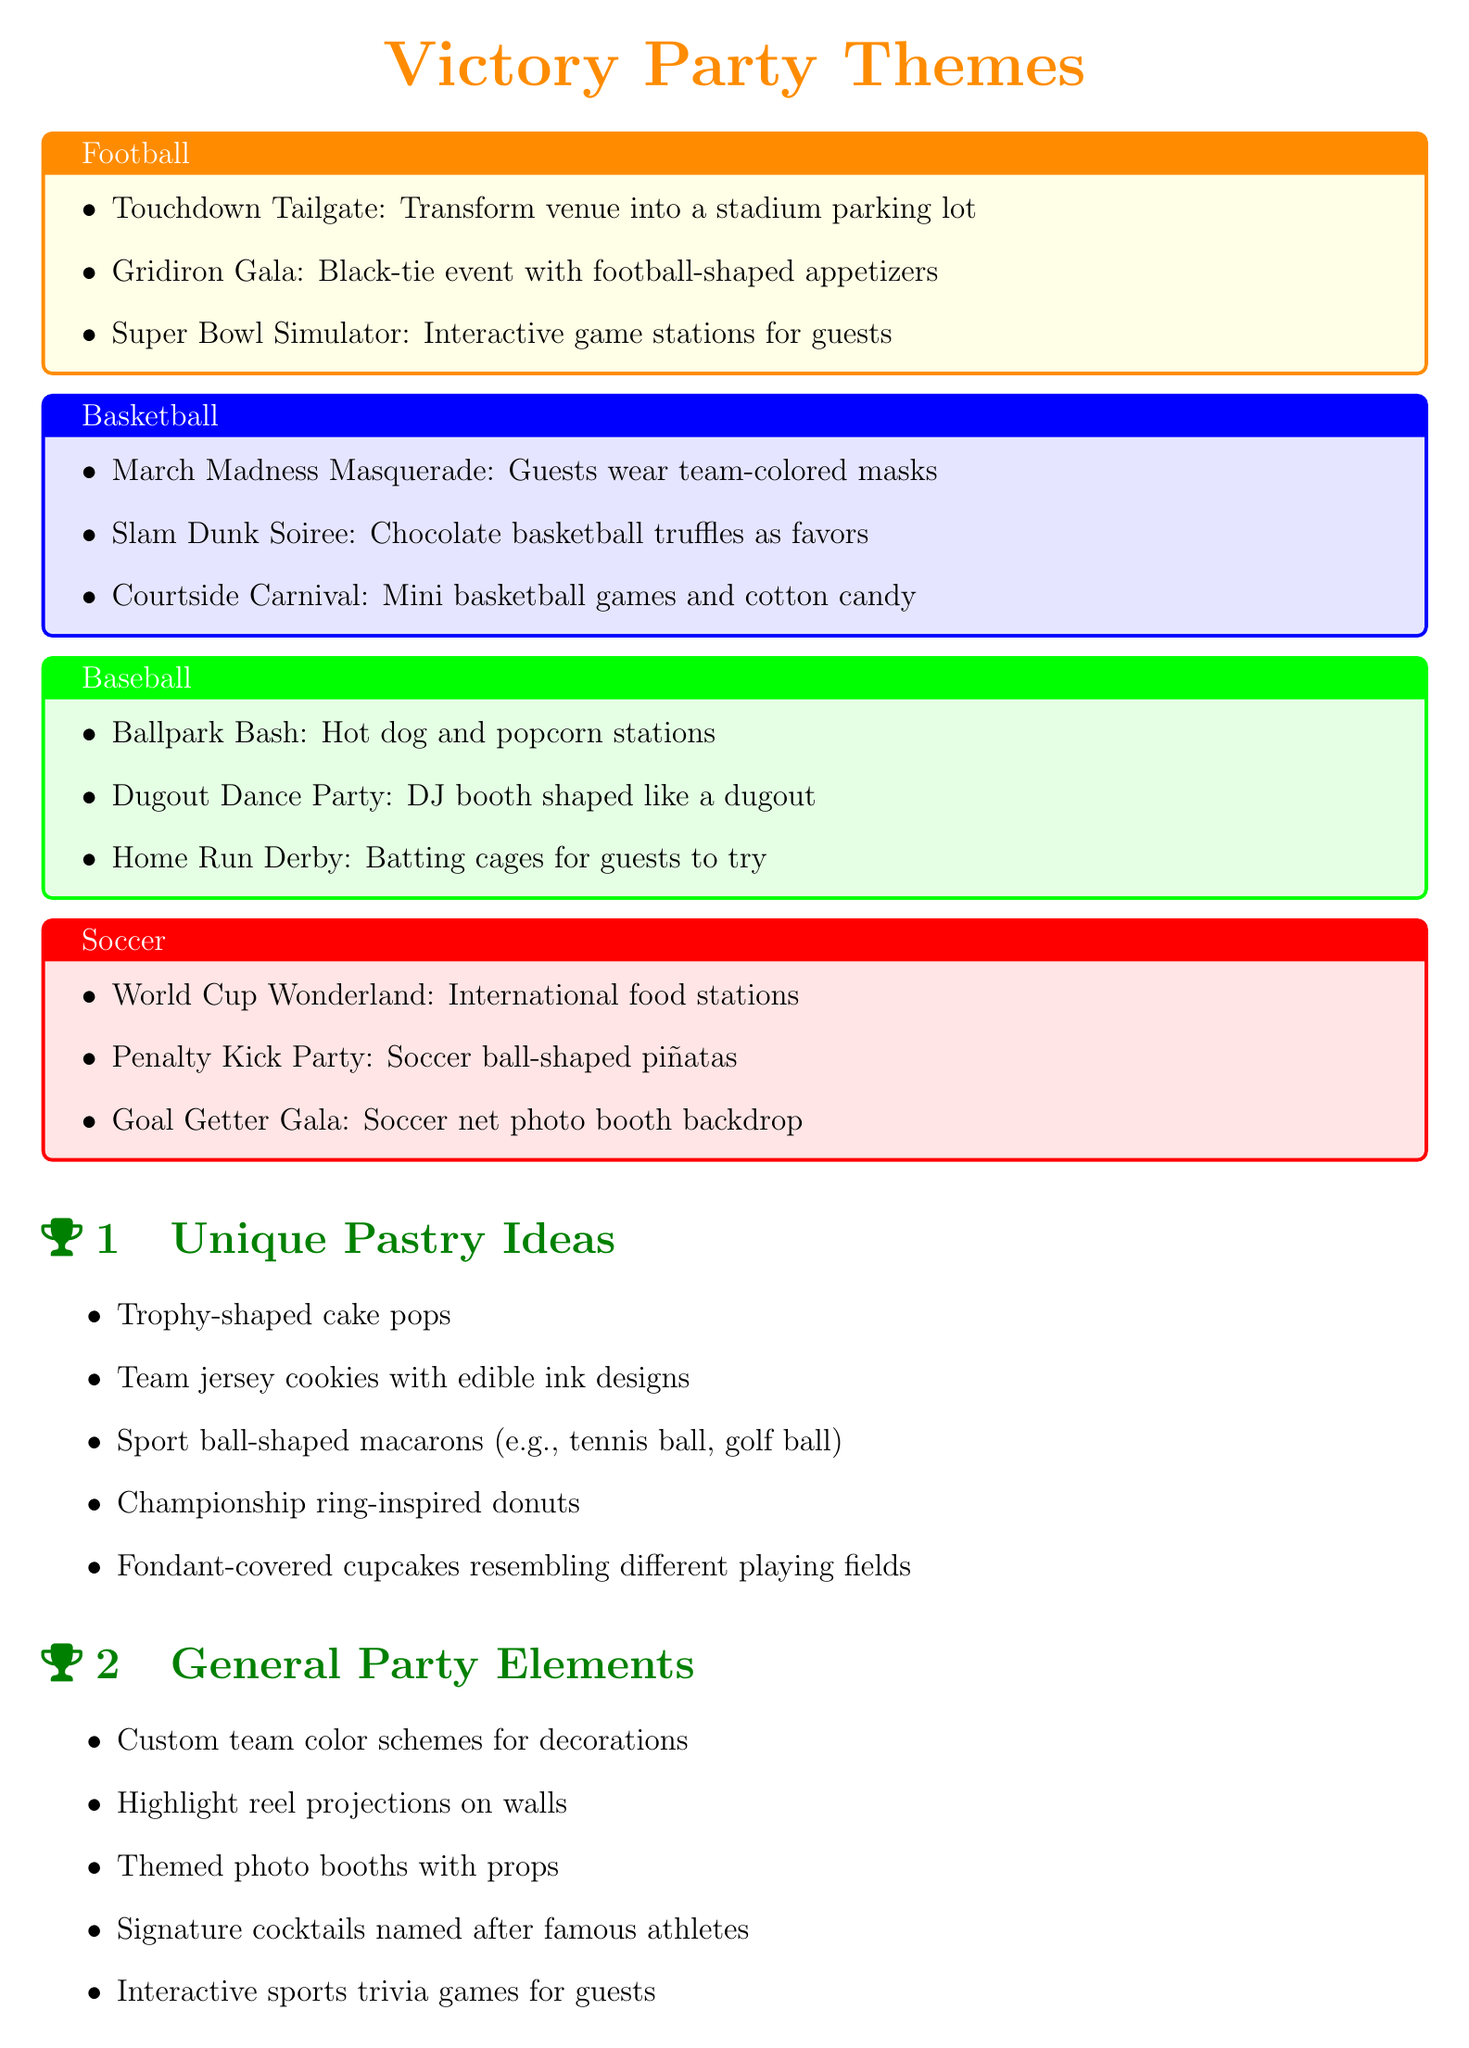What is the theme for the football section? The theme for the football section includes ideas like Touchdown Tailgate, Gridiron Gala, and Super Bowl Simulator.
Answer: Football What type of desserts are suggested for basketball parties? The basketball section suggests favors like chocolate basketball truffles.
Answer: Chocolate basketball truffles What interactive element is included in the soccer party themes? The soccer section includes a photo booth backdrop themed around soccer nets.
Answer: Soccer net photo booth backdrop How many unique pastry ideas are listed in the document? There are five unique pastry ideas provided in the document.
Answer: Five What type of food stations are suggested for the World Cup Wonderland? The World Cup Wonderland suggests having international food stations.
Answer: International food stations Which sport includes a touch-themed event in its party ideas? The touch-themed event is found in the football section with the Touchdown Tailgate idea.
Answer: Football What is a general party element mentioned in the document? Custom team color schemes for decorations is mentioned as a general party element.
Answer: Custom team color schemes What type of activities are suggested in the baseball section? The baseball section suggests activities like hot dog and popcorn stations, and batting cages for guests to try.
Answer: Batting cages for guests to try What type of cocktails are suggested in the general party elements? Signature cocktails named after famous athletes are suggested in the general party elements.
Answer: Signature cocktails 